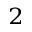<formula> <loc_0><loc_0><loc_500><loc_500>^ { 2 }</formula> 